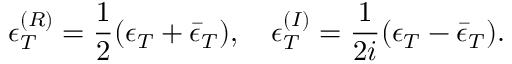Convert formula to latex. <formula><loc_0><loc_0><loc_500><loc_500>\epsilon _ { T } ^ { ( R ) } = \frac { 1 } { 2 } ( \epsilon _ { T } + \bar { \epsilon } _ { T } ) , \quad \epsilon _ { T } ^ { ( I ) } = \frac { 1 } { 2 i } ( \epsilon _ { T } - \bar { \epsilon } _ { T } ) .</formula> 